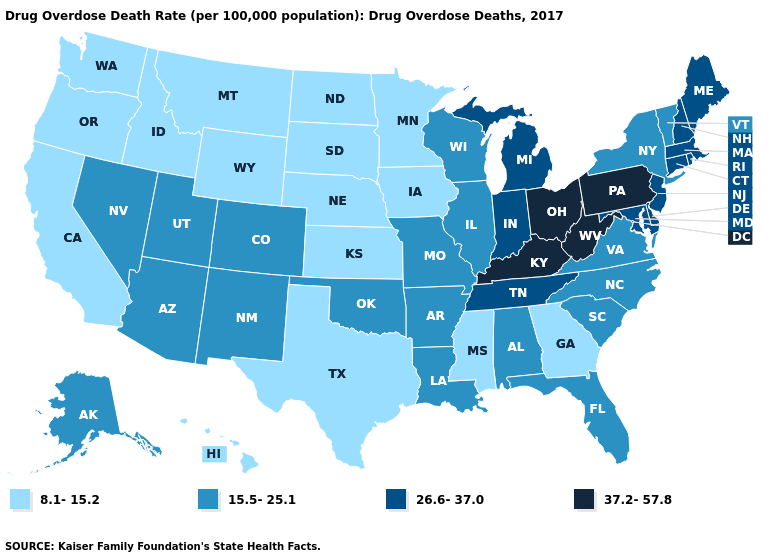What is the value of Montana?
Answer briefly. 8.1-15.2. Is the legend a continuous bar?
Answer briefly. No. Does California have the highest value in the West?
Quick response, please. No. What is the value of Maryland?
Quick response, please. 26.6-37.0. What is the value of Colorado?
Write a very short answer. 15.5-25.1. What is the value of Pennsylvania?
Quick response, please. 37.2-57.8. Does New York have a higher value than Georgia?
Short answer required. Yes. What is the highest value in the USA?
Keep it brief. 37.2-57.8. Does Missouri have the lowest value in the MidWest?
Write a very short answer. No. What is the highest value in the South ?
Concise answer only. 37.2-57.8. Name the states that have a value in the range 15.5-25.1?
Give a very brief answer. Alabama, Alaska, Arizona, Arkansas, Colorado, Florida, Illinois, Louisiana, Missouri, Nevada, New Mexico, New York, North Carolina, Oklahoma, South Carolina, Utah, Vermont, Virginia, Wisconsin. Name the states that have a value in the range 8.1-15.2?
Write a very short answer. California, Georgia, Hawaii, Idaho, Iowa, Kansas, Minnesota, Mississippi, Montana, Nebraska, North Dakota, Oregon, South Dakota, Texas, Washington, Wyoming. Name the states that have a value in the range 37.2-57.8?
Keep it brief. Kentucky, Ohio, Pennsylvania, West Virginia. What is the lowest value in states that border New York?
Quick response, please. 15.5-25.1. Name the states that have a value in the range 26.6-37.0?
Answer briefly. Connecticut, Delaware, Indiana, Maine, Maryland, Massachusetts, Michigan, New Hampshire, New Jersey, Rhode Island, Tennessee. 